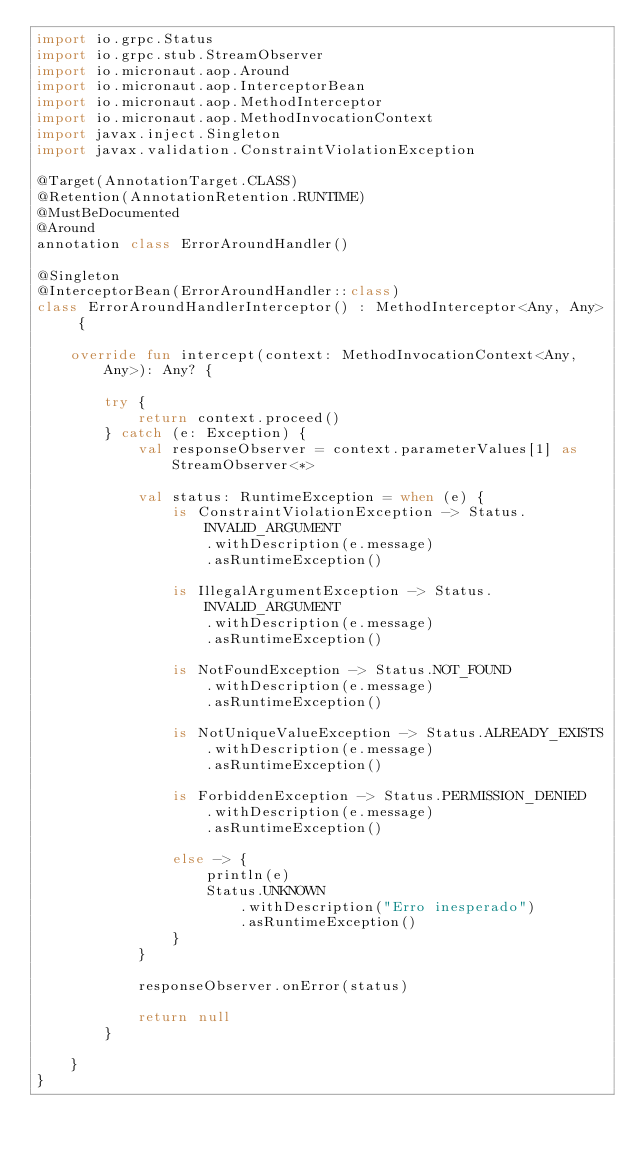Convert code to text. <code><loc_0><loc_0><loc_500><loc_500><_Kotlin_>import io.grpc.Status
import io.grpc.stub.StreamObserver
import io.micronaut.aop.Around
import io.micronaut.aop.InterceptorBean
import io.micronaut.aop.MethodInterceptor
import io.micronaut.aop.MethodInvocationContext
import javax.inject.Singleton
import javax.validation.ConstraintViolationException

@Target(AnnotationTarget.CLASS)
@Retention(AnnotationRetention.RUNTIME)
@MustBeDocumented
@Around
annotation class ErrorAroundHandler()

@Singleton
@InterceptorBean(ErrorAroundHandler::class)
class ErrorAroundHandlerInterceptor() : MethodInterceptor<Any, Any> {

    override fun intercept(context: MethodInvocationContext<Any, Any>): Any? {

        try {
            return context.proceed()
        } catch (e: Exception) {
            val responseObserver = context.parameterValues[1] as StreamObserver<*>

            val status: RuntimeException = when (e) {
                is ConstraintViolationException -> Status.INVALID_ARGUMENT
                    .withDescription(e.message)
                    .asRuntimeException()

                is IllegalArgumentException -> Status.INVALID_ARGUMENT
                    .withDescription(e.message)
                    .asRuntimeException()

                is NotFoundException -> Status.NOT_FOUND
                    .withDescription(e.message)
                    .asRuntimeException()

                is NotUniqueValueException -> Status.ALREADY_EXISTS
                    .withDescription(e.message)
                    .asRuntimeException()

                is ForbiddenException -> Status.PERMISSION_DENIED
                    .withDescription(e.message)
                    .asRuntimeException()

                else -> {
                    println(e)
                    Status.UNKNOWN
                        .withDescription("Erro inesperado")
                        .asRuntimeException()
                }
            }

            responseObserver.onError(status)

            return null
        }

    }
}</code> 